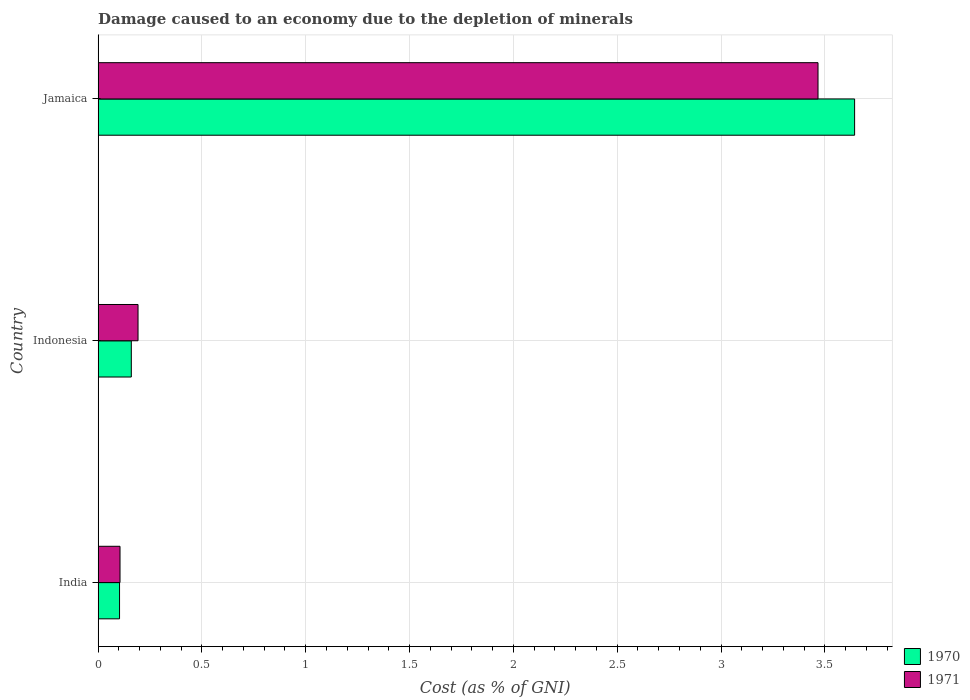How many different coloured bars are there?
Give a very brief answer. 2. How many groups of bars are there?
Your response must be concise. 3. Are the number of bars on each tick of the Y-axis equal?
Make the answer very short. Yes. How many bars are there on the 2nd tick from the top?
Your response must be concise. 2. What is the label of the 3rd group of bars from the top?
Offer a terse response. India. What is the cost of damage caused due to the depletion of minerals in 1970 in Jamaica?
Make the answer very short. 3.64. Across all countries, what is the maximum cost of damage caused due to the depletion of minerals in 1970?
Provide a succinct answer. 3.64. Across all countries, what is the minimum cost of damage caused due to the depletion of minerals in 1970?
Offer a very short reply. 0.1. In which country was the cost of damage caused due to the depletion of minerals in 1970 maximum?
Make the answer very short. Jamaica. In which country was the cost of damage caused due to the depletion of minerals in 1971 minimum?
Keep it short and to the point. India. What is the total cost of damage caused due to the depletion of minerals in 1971 in the graph?
Your response must be concise. 3.76. What is the difference between the cost of damage caused due to the depletion of minerals in 1970 in India and that in Indonesia?
Your response must be concise. -0.06. What is the difference between the cost of damage caused due to the depletion of minerals in 1971 in India and the cost of damage caused due to the depletion of minerals in 1970 in Jamaica?
Your response must be concise. -3.54. What is the average cost of damage caused due to the depletion of minerals in 1970 per country?
Provide a short and direct response. 1.3. What is the difference between the cost of damage caused due to the depletion of minerals in 1970 and cost of damage caused due to the depletion of minerals in 1971 in Indonesia?
Provide a short and direct response. -0.03. In how many countries, is the cost of damage caused due to the depletion of minerals in 1970 greater than 0.5 %?
Provide a succinct answer. 1. What is the ratio of the cost of damage caused due to the depletion of minerals in 1971 in India to that in Indonesia?
Offer a very short reply. 0.55. Is the cost of damage caused due to the depletion of minerals in 1971 in India less than that in Jamaica?
Provide a succinct answer. Yes. What is the difference between the highest and the second highest cost of damage caused due to the depletion of minerals in 1970?
Make the answer very short. 3.48. What is the difference between the highest and the lowest cost of damage caused due to the depletion of minerals in 1970?
Provide a short and direct response. 3.54. In how many countries, is the cost of damage caused due to the depletion of minerals in 1971 greater than the average cost of damage caused due to the depletion of minerals in 1971 taken over all countries?
Keep it short and to the point. 1. What does the 1st bar from the top in Indonesia represents?
Your answer should be very brief. 1971. What does the 1st bar from the bottom in India represents?
Provide a short and direct response. 1970. How many countries are there in the graph?
Give a very brief answer. 3. Does the graph contain grids?
Give a very brief answer. Yes. Where does the legend appear in the graph?
Your response must be concise. Bottom right. How many legend labels are there?
Ensure brevity in your answer.  2. How are the legend labels stacked?
Your answer should be very brief. Vertical. What is the title of the graph?
Offer a very short reply. Damage caused to an economy due to the depletion of minerals. Does "1976" appear as one of the legend labels in the graph?
Provide a succinct answer. No. What is the label or title of the X-axis?
Keep it short and to the point. Cost (as % of GNI). What is the label or title of the Y-axis?
Your response must be concise. Country. What is the Cost (as % of GNI) of 1970 in India?
Keep it short and to the point. 0.1. What is the Cost (as % of GNI) in 1971 in India?
Your answer should be compact. 0.11. What is the Cost (as % of GNI) of 1970 in Indonesia?
Your answer should be compact. 0.16. What is the Cost (as % of GNI) of 1971 in Indonesia?
Your answer should be compact. 0.19. What is the Cost (as % of GNI) in 1970 in Jamaica?
Your answer should be very brief. 3.64. What is the Cost (as % of GNI) in 1971 in Jamaica?
Ensure brevity in your answer.  3.47. Across all countries, what is the maximum Cost (as % of GNI) in 1970?
Your response must be concise. 3.64. Across all countries, what is the maximum Cost (as % of GNI) of 1971?
Provide a short and direct response. 3.47. Across all countries, what is the minimum Cost (as % of GNI) of 1970?
Your response must be concise. 0.1. Across all countries, what is the minimum Cost (as % of GNI) of 1971?
Ensure brevity in your answer.  0.11. What is the total Cost (as % of GNI) in 1970 in the graph?
Ensure brevity in your answer.  3.91. What is the total Cost (as % of GNI) in 1971 in the graph?
Your response must be concise. 3.76. What is the difference between the Cost (as % of GNI) of 1970 in India and that in Indonesia?
Offer a terse response. -0.06. What is the difference between the Cost (as % of GNI) in 1971 in India and that in Indonesia?
Provide a short and direct response. -0.09. What is the difference between the Cost (as % of GNI) of 1970 in India and that in Jamaica?
Ensure brevity in your answer.  -3.54. What is the difference between the Cost (as % of GNI) of 1971 in India and that in Jamaica?
Your answer should be compact. -3.36. What is the difference between the Cost (as % of GNI) of 1970 in Indonesia and that in Jamaica?
Give a very brief answer. -3.48. What is the difference between the Cost (as % of GNI) in 1971 in Indonesia and that in Jamaica?
Make the answer very short. -3.27. What is the difference between the Cost (as % of GNI) in 1970 in India and the Cost (as % of GNI) in 1971 in Indonesia?
Give a very brief answer. -0.09. What is the difference between the Cost (as % of GNI) in 1970 in India and the Cost (as % of GNI) in 1971 in Jamaica?
Your response must be concise. -3.36. What is the difference between the Cost (as % of GNI) in 1970 in Indonesia and the Cost (as % of GNI) in 1971 in Jamaica?
Make the answer very short. -3.31. What is the average Cost (as % of GNI) in 1970 per country?
Keep it short and to the point. 1.3. What is the average Cost (as % of GNI) in 1971 per country?
Keep it short and to the point. 1.25. What is the difference between the Cost (as % of GNI) in 1970 and Cost (as % of GNI) in 1971 in India?
Your answer should be very brief. -0. What is the difference between the Cost (as % of GNI) in 1970 and Cost (as % of GNI) in 1971 in Indonesia?
Provide a succinct answer. -0.03. What is the difference between the Cost (as % of GNI) of 1970 and Cost (as % of GNI) of 1971 in Jamaica?
Ensure brevity in your answer.  0.18. What is the ratio of the Cost (as % of GNI) of 1970 in India to that in Indonesia?
Give a very brief answer. 0.65. What is the ratio of the Cost (as % of GNI) of 1971 in India to that in Indonesia?
Give a very brief answer. 0.55. What is the ratio of the Cost (as % of GNI) of 1970 in India to that in Jamaica?
Make the answer very short. 0.03. What is the ratio of the Cost (as % of GNI) of 1971 in India to that in Jamaica?
Keep it short and to the point. 0.03. What is the ratio of the Cost (as % of GNI) in 1970 in Indonesia to that in Jamaica?
Offer a very short reply. 0.04. What is the ratio of the Cost (as % of GNI) of 1971 in Indonesia to that in Jamaica?
Offer a terse response. 0.06. What is the difference between the highest and the second highest Cost (as % of GNI) in 1970?
Your response must be concise. 3.48. What is the difference between the highest and the second highest Cost (as % of GNI) of 1971?
Offer a very short reply. 3.27. What is the difference between the highest and the lowest Cost (as % of GNI) of 1970?
Provide a succinct answer. 3.54. What is the difference between the highest and the lowest Cost (as % of GNI) in 1971?
Provide a succinct answer. 3.36. 